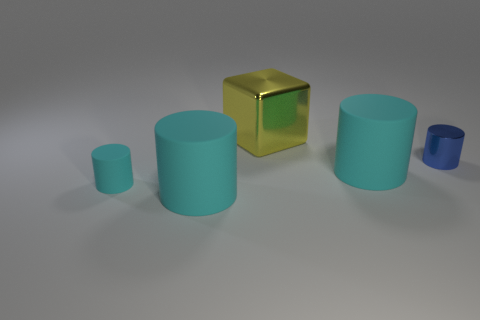How many cyan cylinders must be subtracted to get 1 cyan cylinders? 2 Subtract all blue cubes. How many cyan cylinders are left? 3 Subtract 1 cylinders. How many cylinders are left? 3 Add 4 large green balls. How many objects exist? 9 Subtract all cylinders. How many objects are left? 1 Add 4 large blocks. How many large blocks are left? 5 Add 1 cyan cylinders. How many cyan cylinders exist? 4 Subtract 0 cyan cubes. How many objects are left? 5 Subtract all tiny cyan matte cylinders. Subtract all tiny shiny objects. How many objects are left? 3 